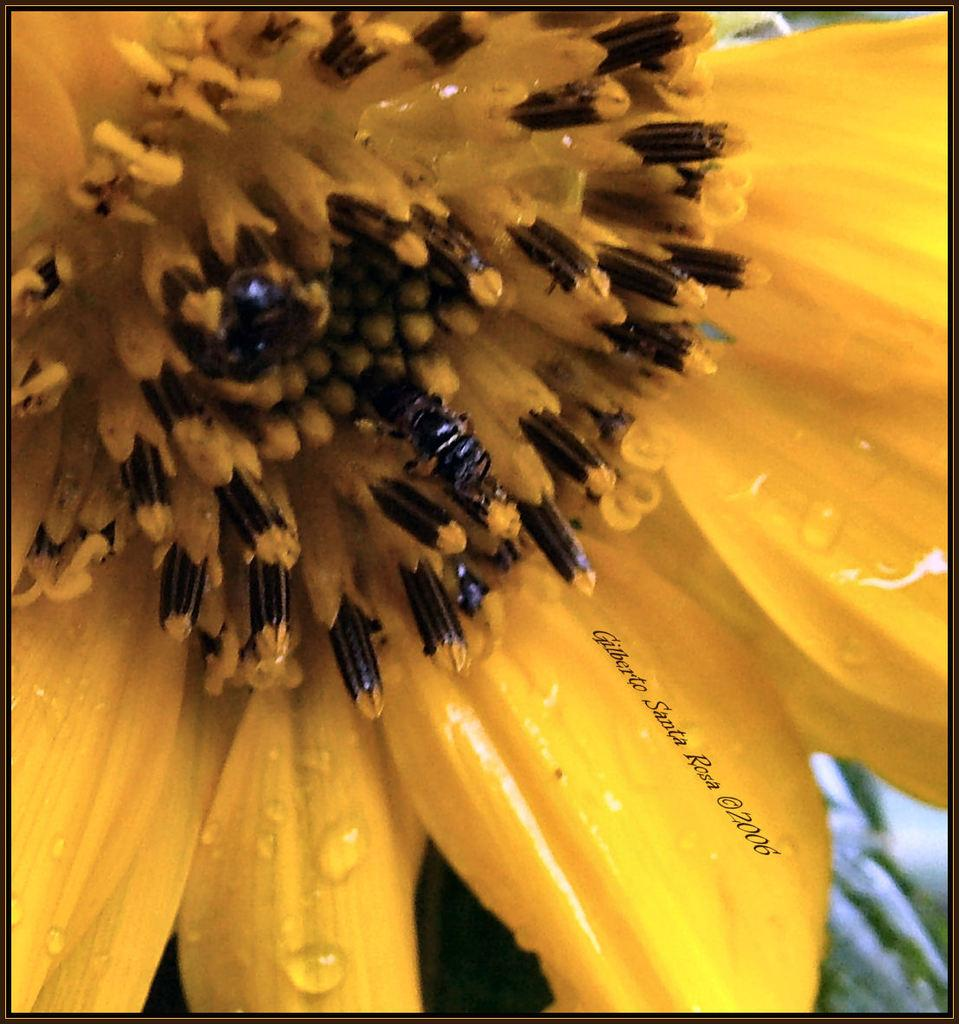What type of flower can be seen in the image? There is a yellow flower in the image. Can you describe any other features of the image? Yes, there is a watermark on the image. What type of shoe is being worn by the flower in the image? There is no shoe present in the image, as the subject is a flower. 